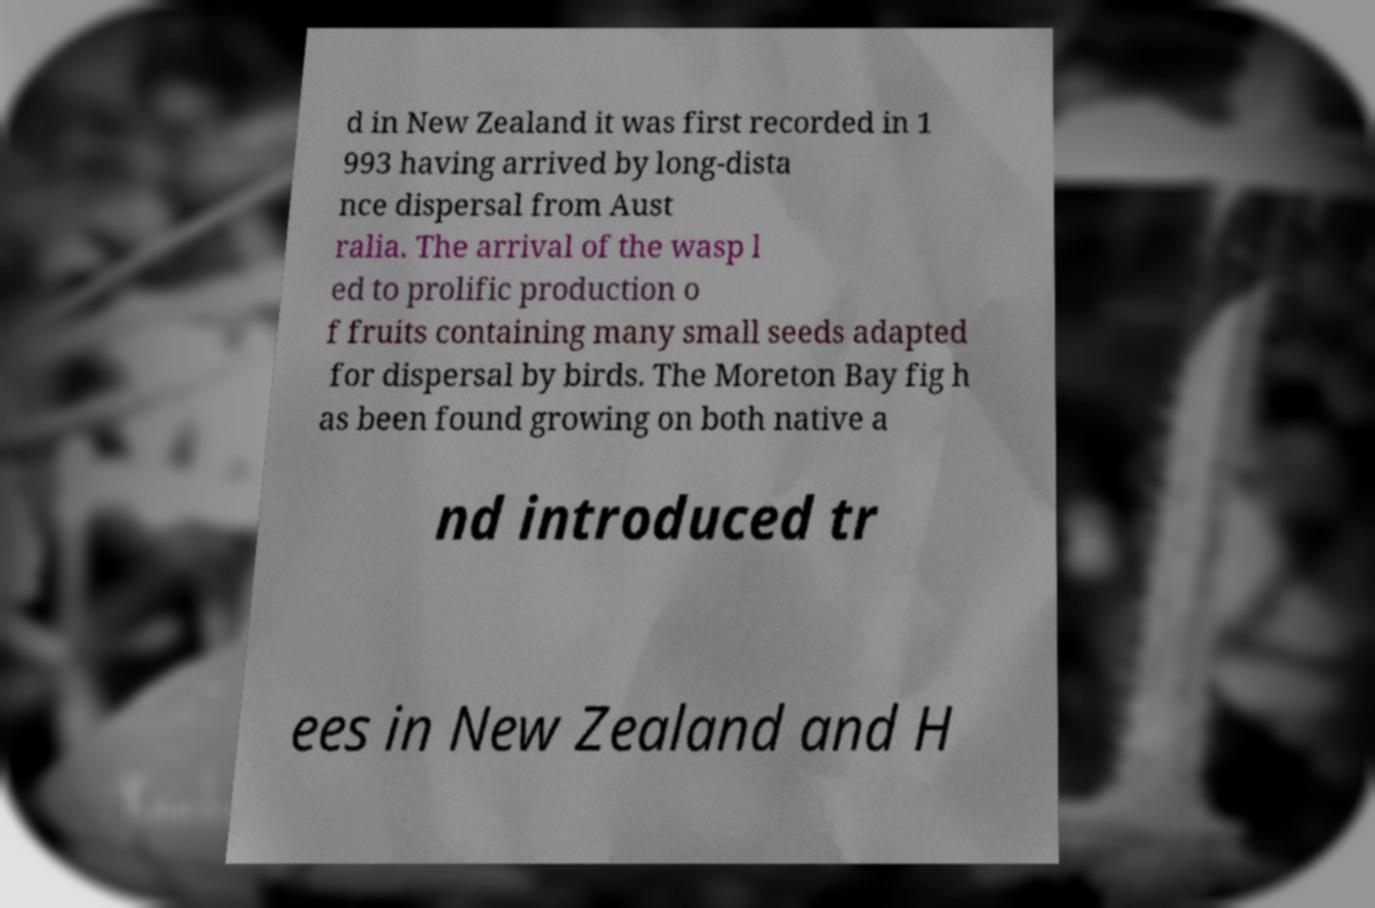Could you assist in decoding the text presented in this image and type it out clearly? d in New Zealand it was first recorded in 1 993 having arrived by long-dista nce dispersal from Aust ralia. The arrival of the wasp l ed to prolific production o f fruits containing many small seeds adapted for dispersal by birds. The Moreton Bay fig h as been found growing on both native a nd introduced tr ees in New Zealand and H 